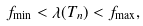Convert formula to latex. <formula><loc_0><loc_0><loc_500><loc_500>f _ { \min } < \lambda ( T _ { n } ) < f _ { \max } ,</formula> 